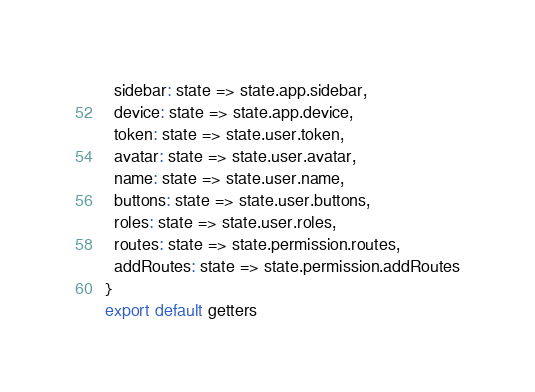Convert code to text. <code><loc_0><loc_0><loc_500><loc_500><_JavaScript_>  sidebar: state => state.app.sidebar,
  device: state => state.app.device,
  token: state => state.user.token,
  avatar: state => state.user.avatar,
  name: state => state.user.name,
  buttons: state => state.user.buttons,
  roles: state => state.user.roles,
  routes: state => state.permission.routes,
  addRoutes: state => state.permission.addRoutes
}
export default getters
</code> 